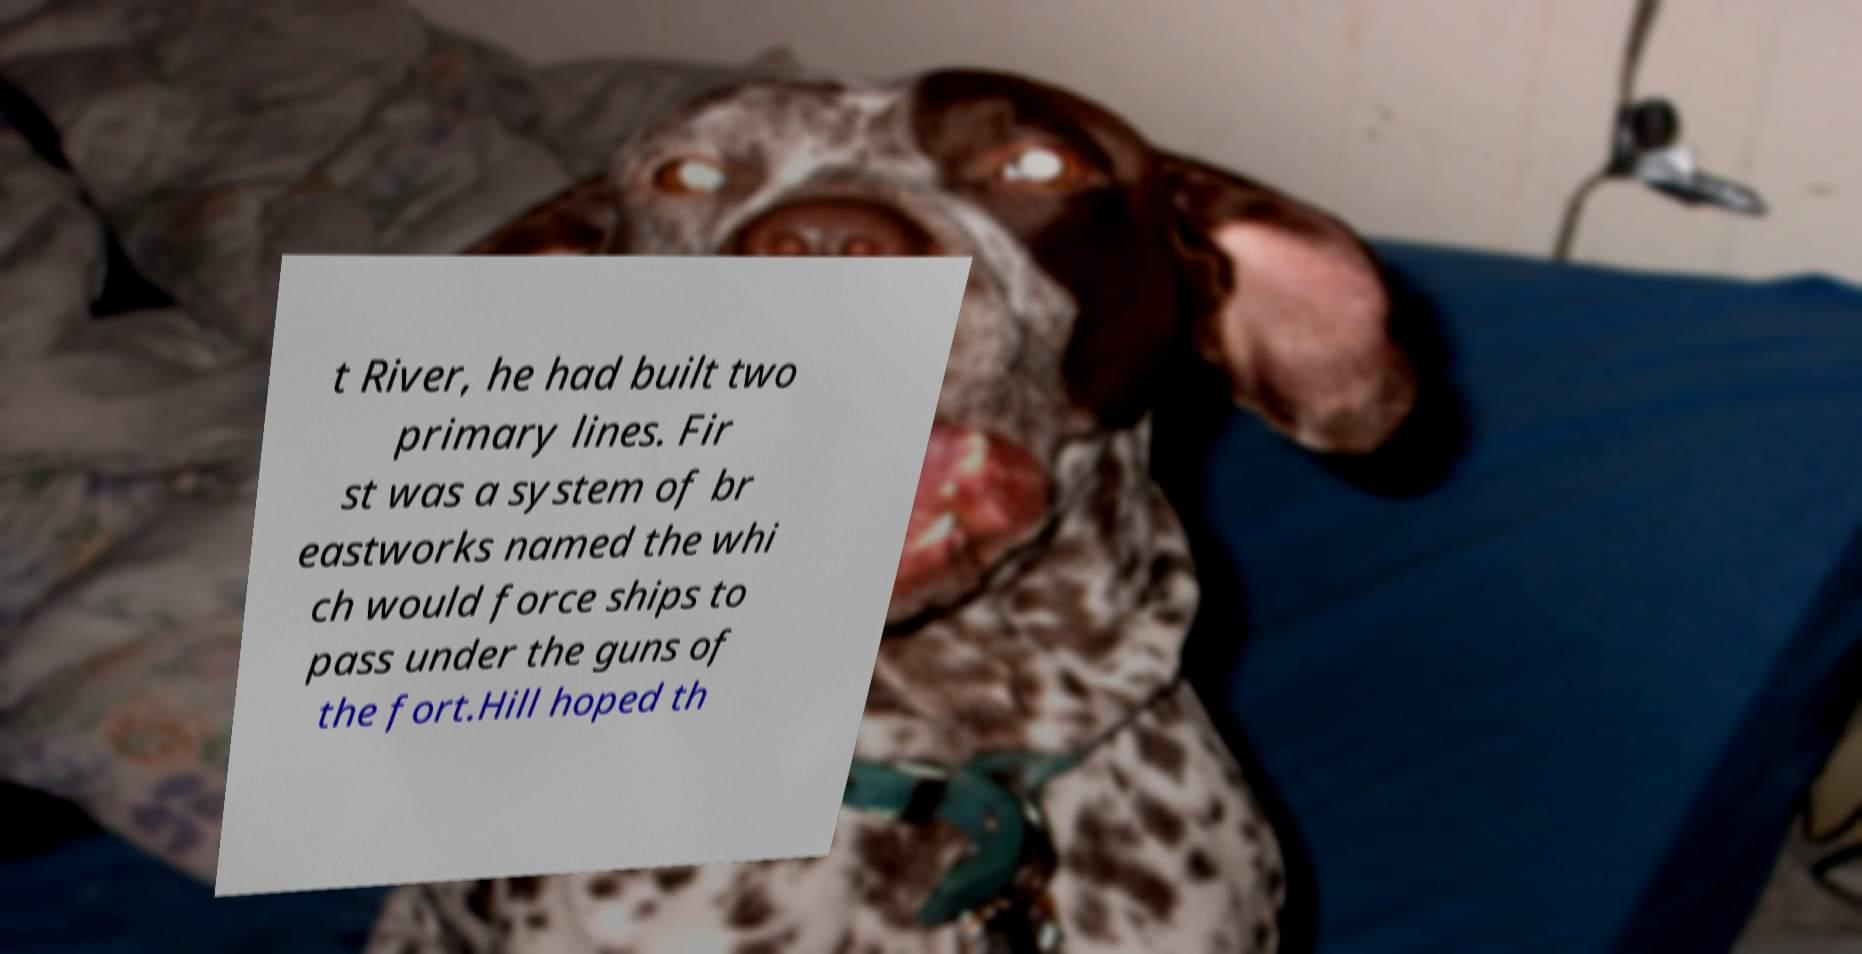I need the written content from this picture converted into text. Can you do that? t River, he had built two primary lines. Fir st was a system of br eastworks named the whi ch would force ships to pass under the guns of the fort.Hill hoped th 